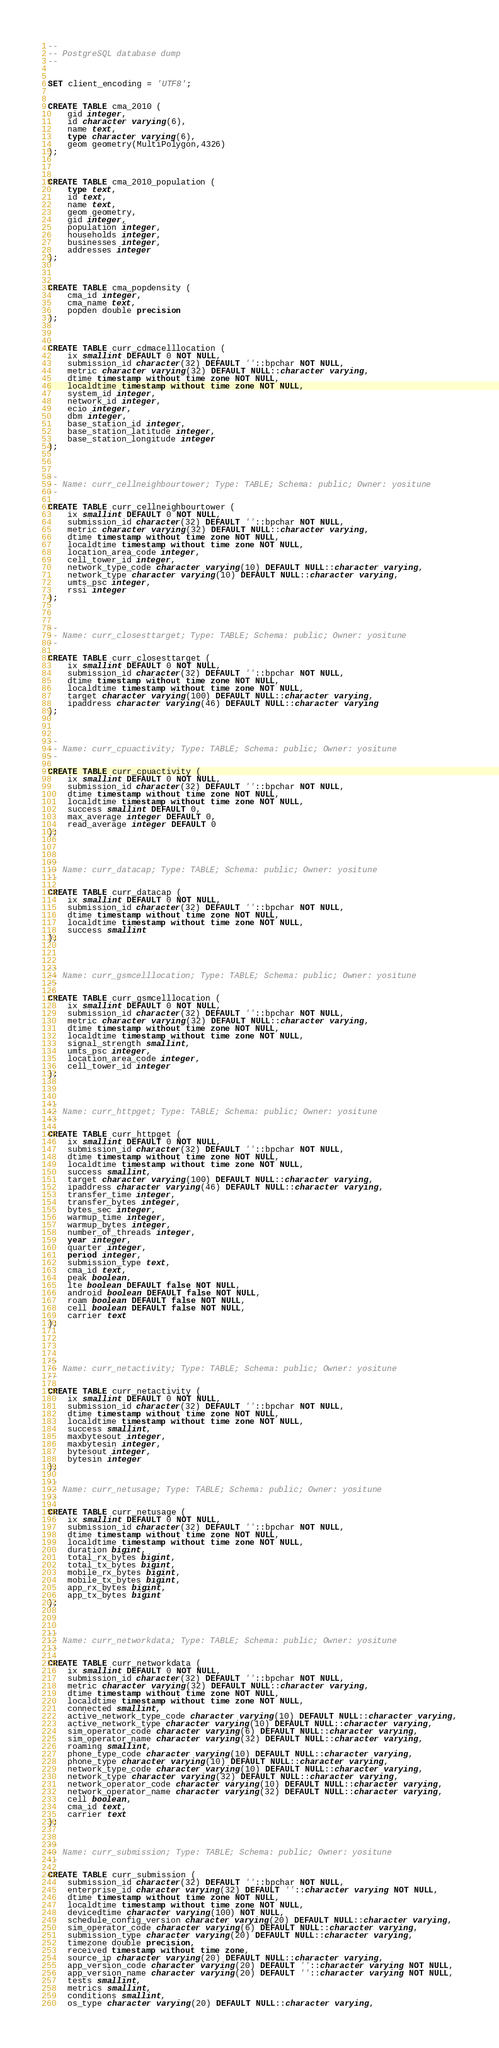Convert code to text. <code><loc_0><loc_0><loc_500><loc_500><_SQL_>--
-- PostgreSQL database dump
--


SET client_encoding = 'UTF8';


CREATE TABLE cma_2010 (
    gid integer,
    id character varying(6),
    name text,
    type character varying(6),
    geom geometry(MultiPolygon,4326)
);



CREATE TABLE cma_2010_population (
    type text,
    id text,
    name text,
    geom geometry,
    gid integer,
    population integer,
    households integer,
    businesses integer,
    addresses integer
);



CREATE TABLE cma_popdensity (
    cma_id integer,
    cma_name text,
    popden double precision
);



CREATE TABLE curr_cdmacelllocation (
    ix smallint DEFAULT 0 NOT NULL,
    submission_id character(32) DEFAULT ''::bpchar NOT NULL,
    metric character varying(32) DEFAULT NULL::character varying,
    dtime timestamp without time zone NOT NULL,
    localdtime timestamp without time zone NOT NULL,
    system_id integer,
    network_id integer,
    ecio integer,
    dbm integer,
    base_station_id integer,
    base_station_latitude integer,
    base_station_longitude integer
);



--
-- Name: curr_cellneighbourtower; Type: TABLE; Schema: public; Owner: yositune
--

CREATE TABLE curr_cellneighbourtower (
    ix smallint DEFAULT 0 NOT NULL,
    submission_id character(32) DEFAULT ''::bpchar NOT NULL,
    metric character varying(32) DEFAULT NULL::character varying,
    dtime timestamp without time zone NOT NULL,
    localdtime timestamp without time zone NOT NULL,
    location_area_code integer,
    cell_tower_id integer,
    network_type_code character varying(10) DEFAULT NULL::character varying,
    network_type character varying(10) DEFAULT NULL::character varying,
    umts_psc integer,
    rssi integer
);



--
-- Name: curr_closesttarget; Type: TABLE; Schema: public; Owner: yositune
--

CREATE TABLE curr_closesttarget (
    ix smallint DEFAULT 0 NOT NULL,
    submission_id character(32) DEFAULT ''::bpchar NOT NULL,
    dtime timestamp without time zone NOT NULL,
    localdtime timestamp without time zone NOT NULL,
    target character varying(100) DEFAULT NULL::character varying,
    ipaddress character varying(46) DEFAULT NULL::character varying
);



--
-- Name: curr_cpuactivity; Type: TABLE; Schema: public; Owner: yositune
--

CREATE TABLE curr_cpuactivity (
    ix smallint DEFAULT 0 NOT NULL,
    submission_id character(32) DEFAULT ''::bpchar NOT NULL,
    dtime timestamp without time zone NOT NULL,
    localdtime timestamp without time zone NOT NULL,
    success smallint DEFAULT 0,
    max_average integer DEFAULT 0,
    read_average integer DEFAULT 0
);



--
-- Name: curr_datacap; Type: TABLE; Schema: public; Owner: yositune
--

CREATE TABLE curr_datacap (
    ix smallint DEFAULT 0 NOT NULL,
    submission_id character(32) DEFAULT ''::bpchar NOT NULL,
    dtime timestamp without time zone NOT NULL,
    localdtime timestamp without time zone NOT NULL,
    success smallint
);



--
-- Name: curr_gsmcelllocation; Type: TABLE; Schema: public; Owner: yositune
--

CREATE TABLE curr_gsmcelllocation (
    ix smallint DEFAULT 0 NOT NULL,
    submission_id character(32) DEFAULT ''::bpchar NOT NULL,
    metric character varying(32) DEFAULT NULL::character varying,
    dtime timestamp without time zone NOT NULL,
    localdtime timestamp without time zone NOT NULL,
    signal_strength smallint,
    umts_psc integer,
    location_area_code integer,
    cell_tower_id integer
);



--
-- Name: curr_httpget; Type: TABLE; Schema: public; Owner: yositune
--

CREATE TABLE curr_httpget (
    ix smallint DEFAULT 0 NOT NULL,
    submission_id character(32) DEFAULT ''::bpchar NOT NULL,
    dtime timestamp without time zone NOT NULL,
    localdtime timestamp without time zone NOT NULL,
    success smallint,
    target character varying(100) DEFAULT NULL::character varying,
    ipaddress character varying(46) DEFAULT NULL::character varying,
    transfer_time integer,
    transfer_bytes integer,
    bytes_sec integer,
    warmup_time integer,
    warmup_bytes integer,
    number_of_threads integer,
    year integer,
    quarter integer,
    period integer,
    submission_type text,
    cma_id text,
    peak boolean,
    lte boolean DEFAULT false NOT NULL,
    android boolean DEFAULT false NOT NULL,
    roam boolean DEFAULT false NOT NULL,
    cell boolean DEFAULT false NOT NULL,
    carrier text
);




--
-- Name: curr_netactivity; Type: TABLE; Schema: public; Owner: yositune
--

CREATE TABLE curr_netactivity (
    ix smallint DEFAULT 0 NOT NULL,
    submission_id character(32) DEFAULT ''::bpchar NOT NULL,
    dtime timestamp without time zone NOT NULL,
    localdtime timestamp without time zone NOT NULL,
    success smallint,
    maxbytesout integer,
    maxbytesin integer,
    bytesout integer,
    bytesin integer
);

--
-- Name: curr_netusage; Type: TABLE; Schema: public; Owner: yositune
--

CREATE TABLE curr_netusage (
    ix smallint DEFAULT 0 NOT NULL,
    submission_id character(32) DEFAULT ''::bpchar NOT NULL,
    dtime timestamp without time zone NOT NULL,
    localdtime timestamp without time zone NOT NULL,
    duration bigint,
    total_rx_bytes bigint,
    total_tx_bytes bigint,
    mobile_rx_bytes bigint,
    mobile_tx_bytes bigint,
    app_rx_bytes bigint,
    app_tx_bytes bigint
);



--
-- Name: curr_networkdata; Type: TABLE; Schema: public; Owner: yositune
--

CREATE TABLE curr_networkdata (
    ix smallint DEFAULT 0 NOT NULL,
    submission_id character(32) DEFAULT ''::bpchar NOT NULL,
    metric character varying(32) DEFAULT NULL::character varying,
    dtime timestamp without time zone NOT NULL,
    localdtime timestamp without time zone NOT NULL,
    connected smallint,
    active_network_type_code character varying(10) DEFAULT NULL::character varying,
    active_network_type character varying(10) DEFAULT NULL::character varying,
    sim_operator_code character varying(6) DEFAULT NULL::character varying,
    sim_operator_name character varying(32) DEFAULT NULL::character varying,
    roaming smallint,
    phone_type_code character varying(10) DEFAULT NULL::character varying,
    phone_type character varying(10) DEFAULT NULL::character varying,
    network_type_code character varying(10) DEFAULT NULL::character varying,
    network_type character varying(32) DEFAULT NULL::character varying,
    network_operator_code character varying(10) DEFAULT NULL::character varying,
    network_operator_name character varying(32) DEFAULT NULL::character varying,
    cell boolean,
    cma_id text,
    carrier text
);


--
-- Name: curr_submission; Type: TABLE; Schema: public; Owner: yositune
--

CREATE TABLE curr_submission (
    submission_id character(32) DEFAULT ''::bpchar NOT NULL,
    enterprise_id character varying(32) DEFAULT ''::character varying NOT NULL,
    dtime timestamp without time zone NOT NULL,
    localdtime timestamp without time zone NOT NULL,
    devicedtime character varying(100) NOT NULL,
    schedule_config_version character varying(20) DEFAULT NULL::character varying,
    sim_operator_code character varying(6) DEFAULT NULL::character varying,
    submission_type character varying(20) DEFAULT NULL::character varying,
    timezone double precision,
    received timestamp without time zone,
    source_ip character varying(20) DEFAULT NULL::character varying,
    app_version_code character varying(20) DEFAULT ''::character varying NOT NULL,
    app_version_name character varying(20) DEFAULT ''::character varying NOT NULL,
    tests smallint,
    metrics smallint,
    conditions smallint,
    os_type character varying(20) DEFAULT NULL::character varying,</code> 